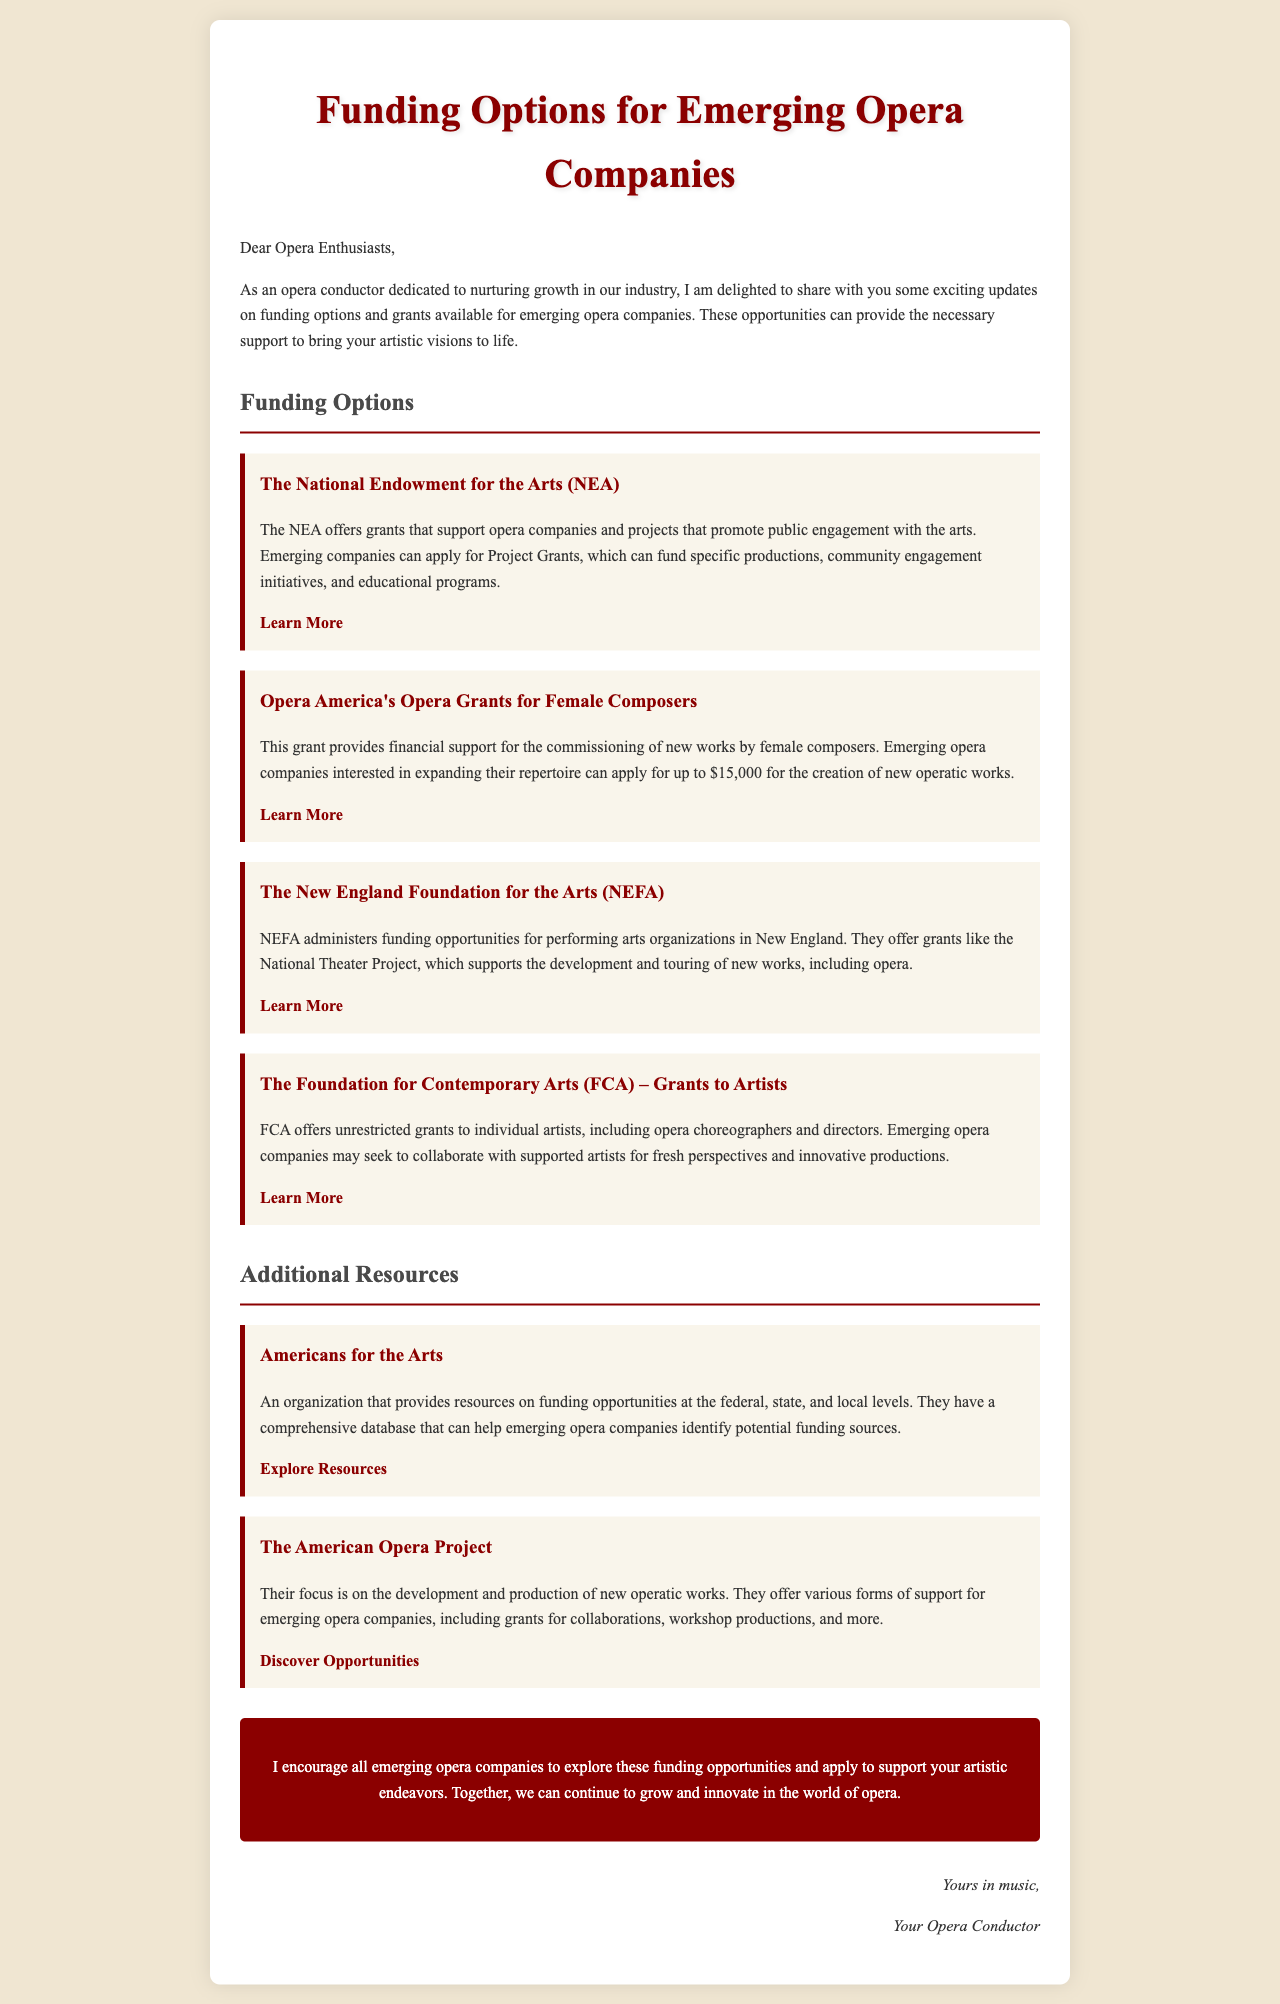What is the title of the document? The title is prominently displayed at the top of the document.
Answer: Funding Options for Emerging Opera Companies What organization offers grants that support opera companies? The National Endowment for the Arts is mentioned as a funding source.
Answer: NEA What grant supports the commissioning of new works by female composers? The specific grant type is highlighted under one of the funding options.
Answer: Opera Grants for Female Composers How much can emerging opera companies apply for the Opera Grants for Female Composers? This information is provided directly in the section about the grant.
Answer: $15,000 What is the focus of The American Opera Project? The description clarifies the mission of this organization.
Answer: Development and production of new operatic works What type of support does The Foundation for Contemporary Arts offer? This refers to the aid available for specific groups of artists.
Answer: Unrestricted grants Which organization provides a comprehensive database for funding opportunities? This detail is included in the resources section.
Answer: Americans for the Arts What does the document encourage emerging opera companies to do? This is stated in the call to action at the end of the document.
Answer: Explore funding opportunities 